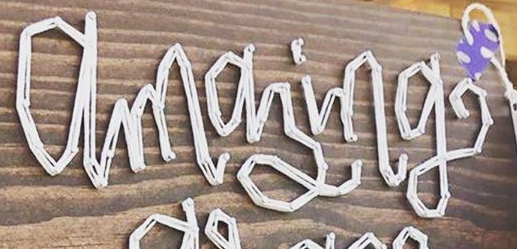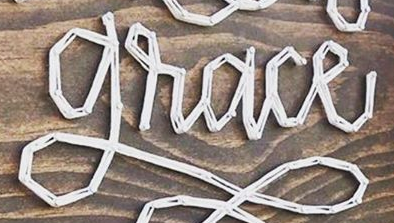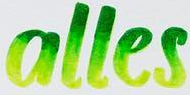Transcribe the words shown in these images in order, separated by a semicolon. amazing; grace; alles 